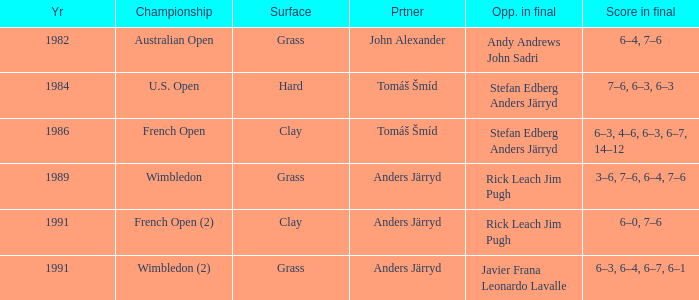What was the surface when he played with John Alexander?  Grass. 